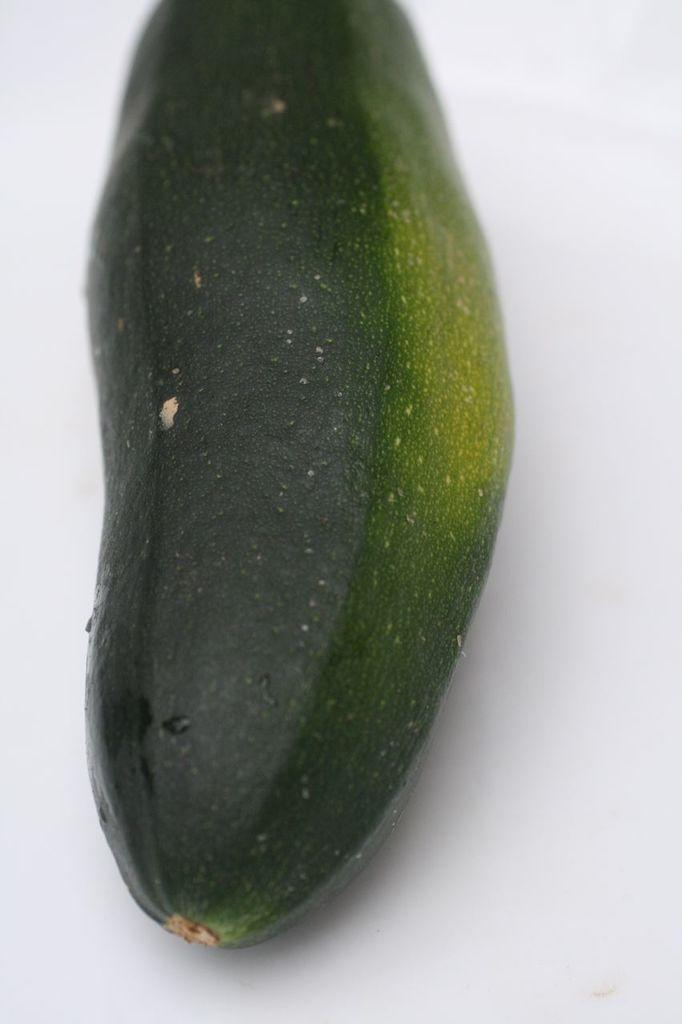What is the main subject of the image? The main subject of the image is a cucumber. What can be said about the color of the cucumber? The cucumber is green in color. On what surface is the cucumber placed? The cucumber is on a white surface. What type of crayon is being used to draw on the cucumber in the image? There is no crayon or drawing present on the cucumber in the image. How many beds are visible in the image? There are no beds visible in the image; it features a cucumber on a white surface. 